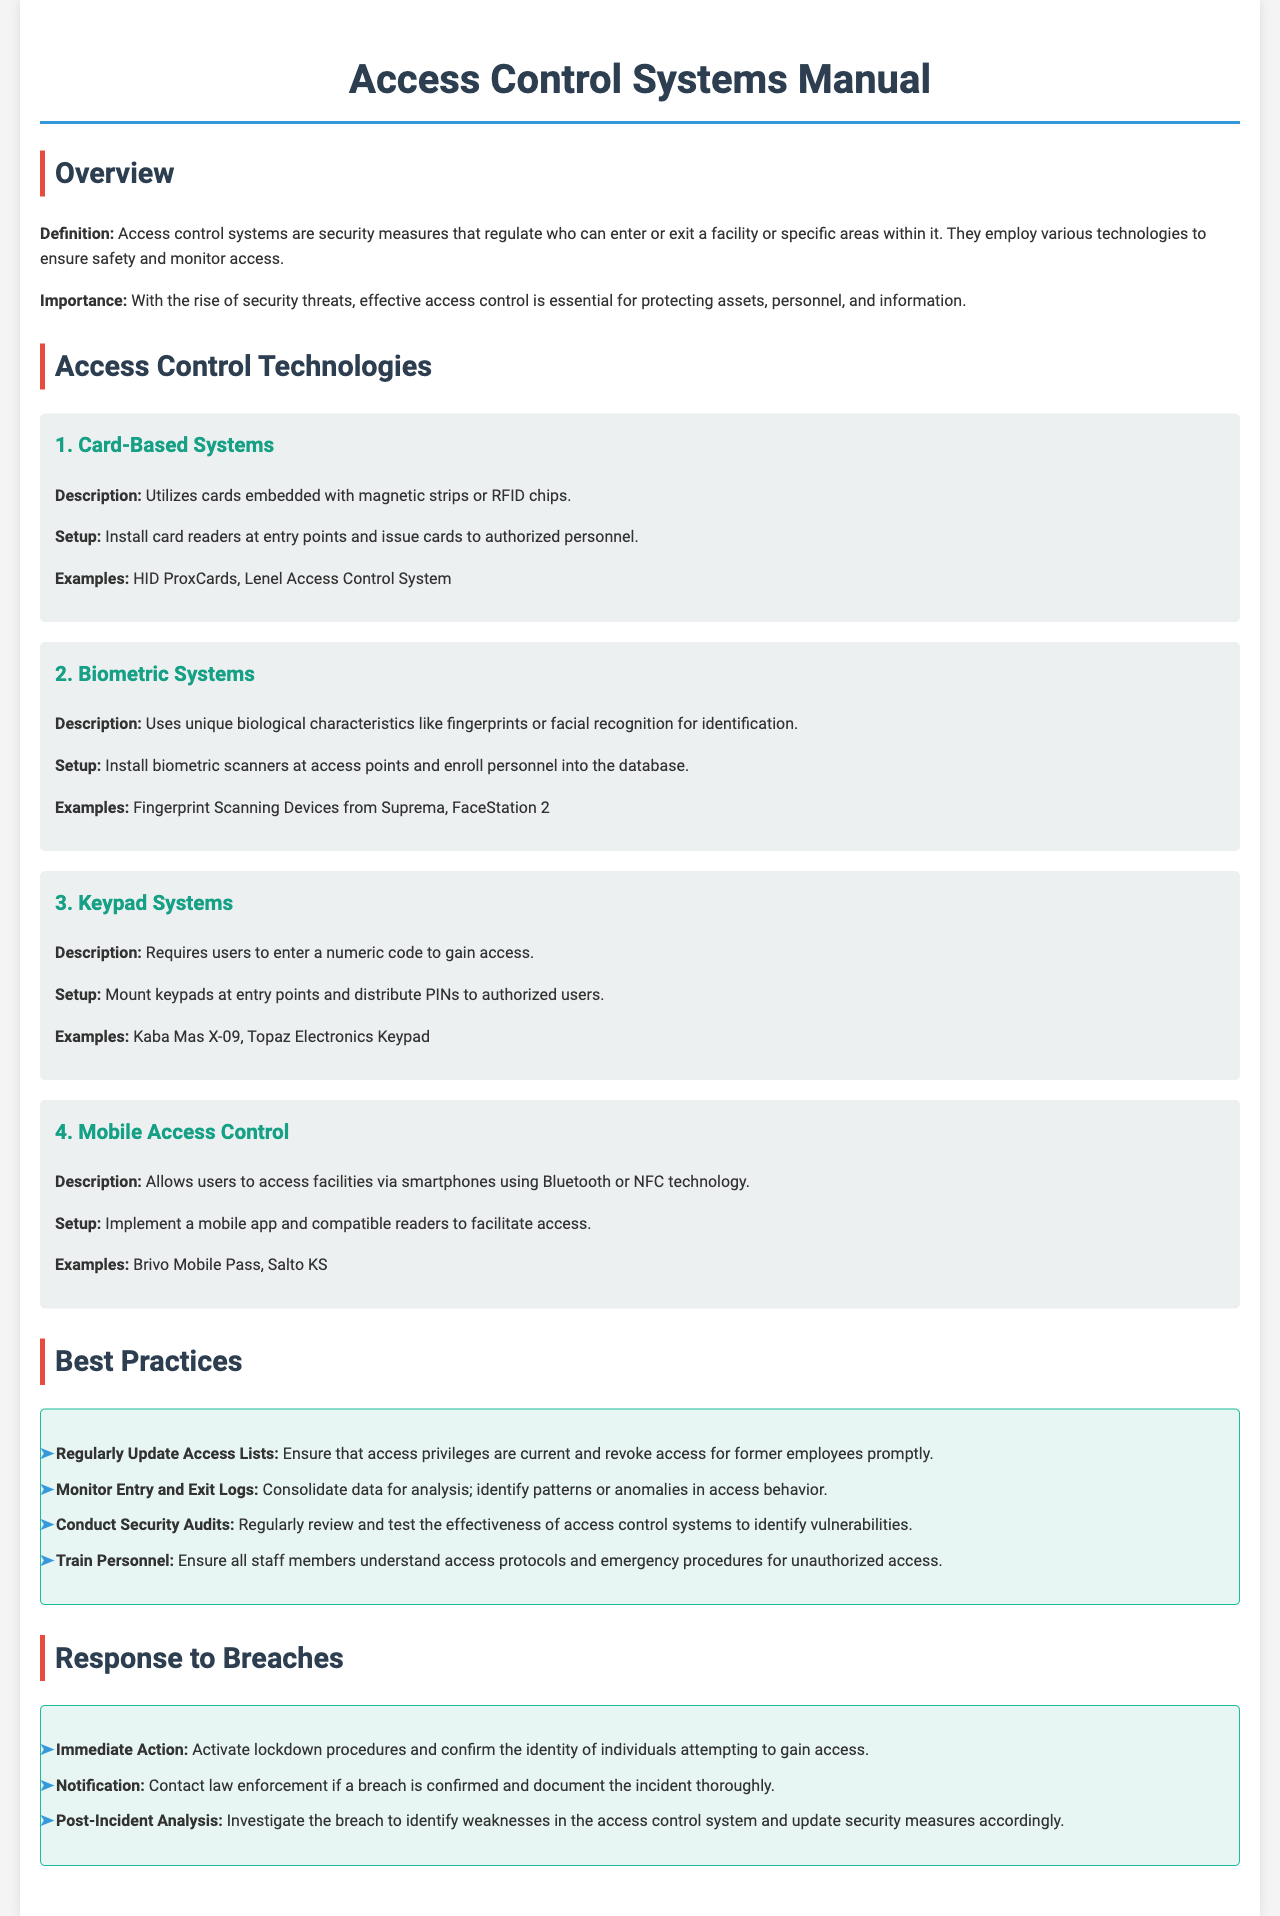What is an access control system? An access control system is a security measure that regulates who can enter or exit a facility or specific areas within it.
Answer: A security measure regulating access What technology uses fingerprints for identification? The document describes biometric systems as using unique biological characteristics like fingerprints for identification.
Answer: Biometric systems How many access control technologies are mentioned in the document? The document lists four different access control technologies, providing descriptions and examples for each.
Answer: Four What should be done with access privileges for former employees? The document advises to ensure that access privileges are current and revoke access for former employees promptly.
Answer: Revoke access What action should be taken immediately after a breach is confirmed? The manual states that immediate action should involve activating lockdown procedures.
Answer: Activate lockdown procedures Which technology allows access via smartphones? The document specifies mobile access control as allowing users to access facilities via smartphones.
Answer: Mobile access control What is the purpose of conducting security audits? The document explains that regular security audits help review and test the effectiveness of access control systems to identify vulnerabilities.
Answer: Identify vulnerabilities Which device is an example of a keypad system? The document cites Kaba Mas X-09 as an example of a keypad system.
Answer: Kaba Mas X-09 What should be done after investigating a breach? Post-incident actions should include updating security measures accordingly.
Answer: Update security measures 